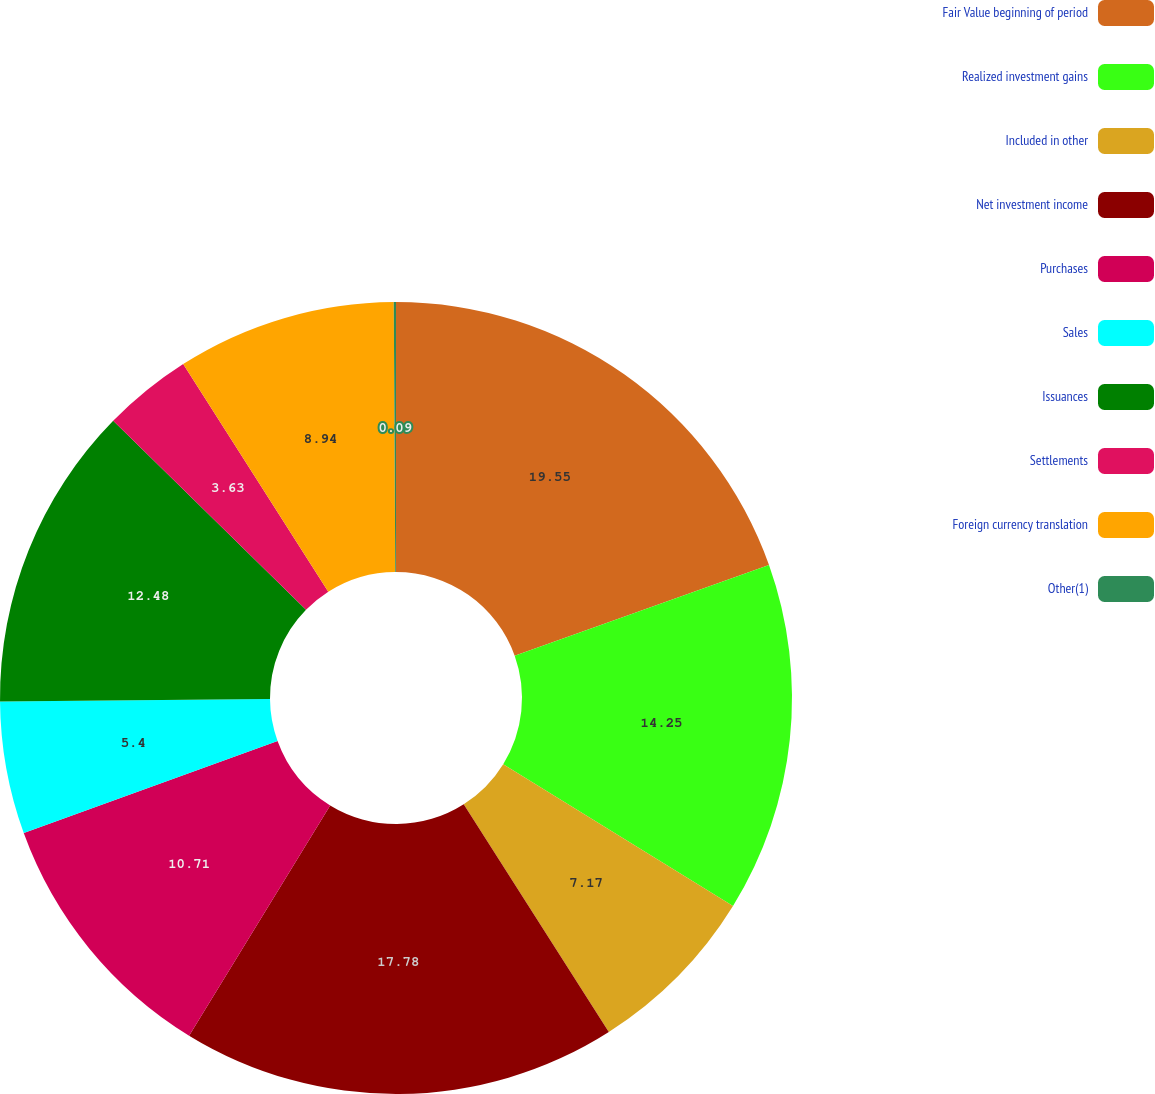Convert chart to OTSL. <chart><loc_0><loc_0><loc_500><loc_500><pie_chart><fcel>Fair Value beginning of period<fcel>Realized investment gains<fcel>Included in other<fcel>Net investment income<fcel>Purchases<fcel>Sales<fcel>Issuances<fcel>Settlements<fcel>Foreign currency translation<fcel>Other(1)<nl><fcel>19.55%<fcel>14.25%<fcel>7.17%<fcel>17.78%<fcel>10.71%<fcel>5.4%<fcel>12.48%<fcel>3.63%<fcel>8.94%<fcel>0.09%<nl></chart> 